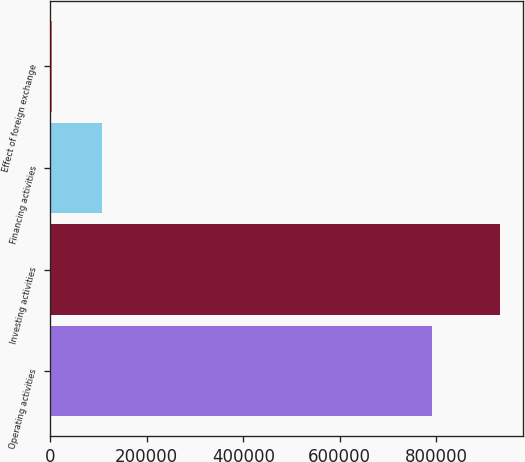Convert chart to OTSL. <chart><loc_0><loc_0><loc_500><loc_500><bar_chart><fcel>Operating activities<fcel>Investing activities<fcel>Financing activities<fcel>Effect of foreign exchange<nl><fcel>792226<fcel>932406<fcel>107320<fcel>3141<nl></chart> 